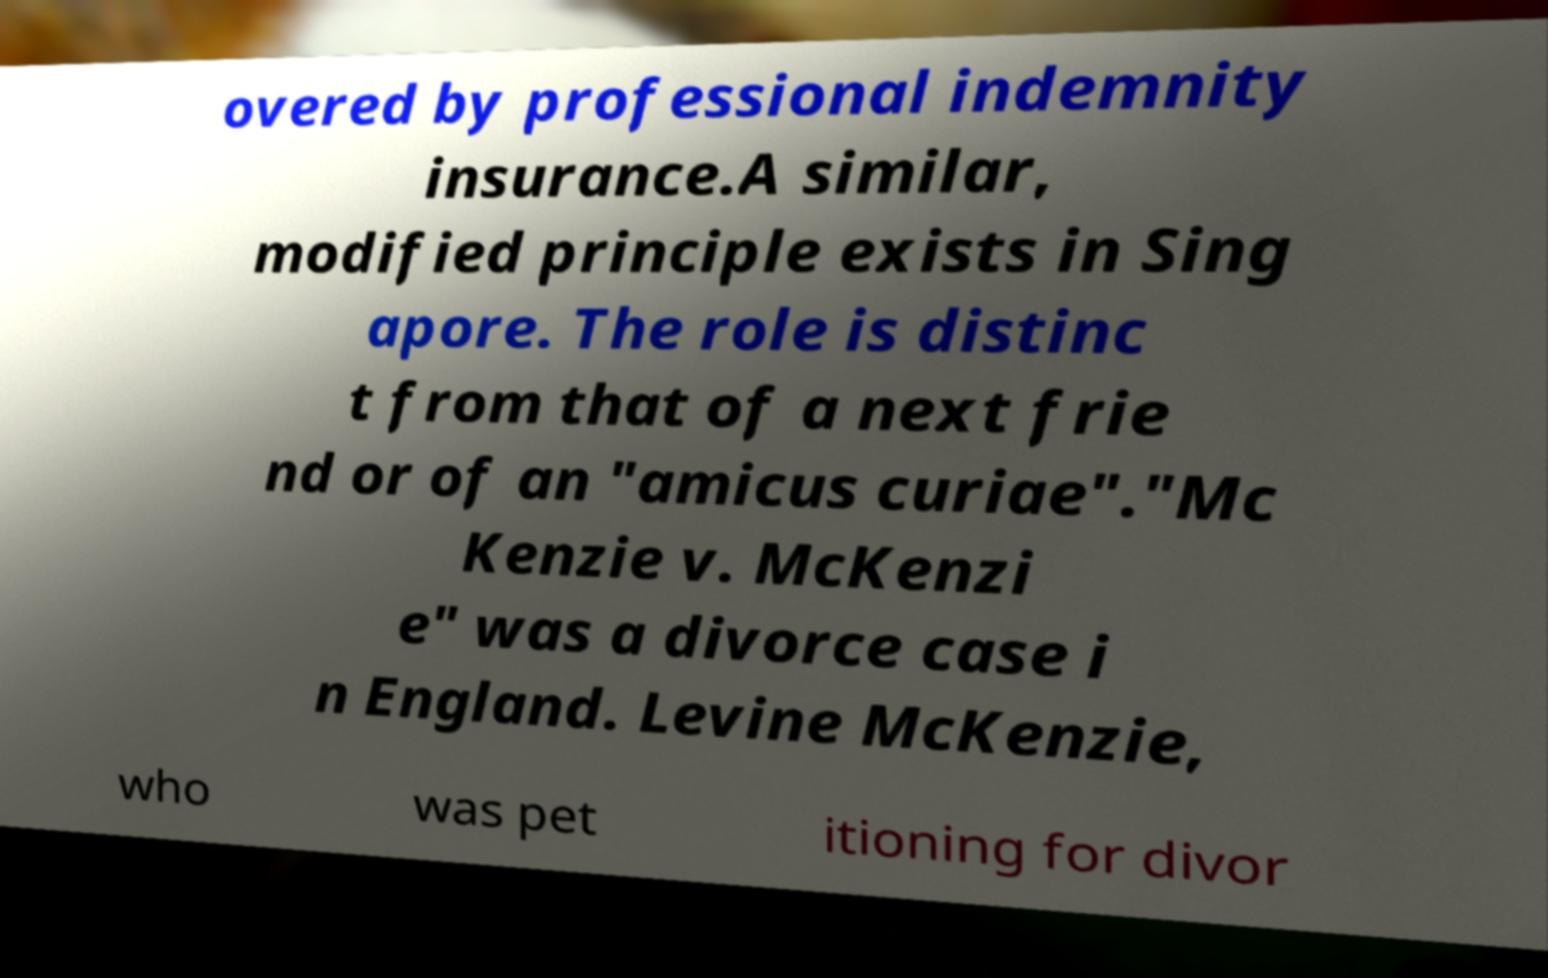There's text embedded in this image that I need extracted. Can you transcribe it verbatim? overed by professional indemnity insurance.A similar, modified principle exists in Sing apore. The role is distinc t from that of a next frie nd or of an "amicus curiae"."Mc Kenzie v. McKenzi e" was a divorce case i n England. Levine McKenzie, who was pet itioning for divor 